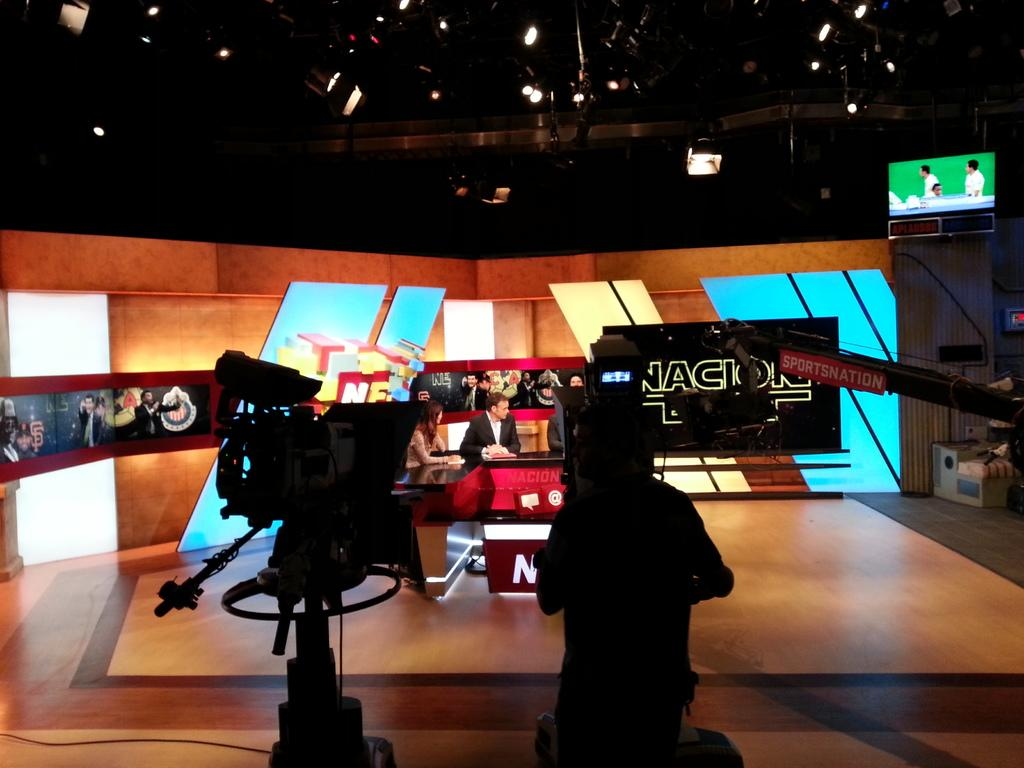<image>
Offer a succinct explanation of the picture presented. An episode of Nacion is being filmed on a set. 